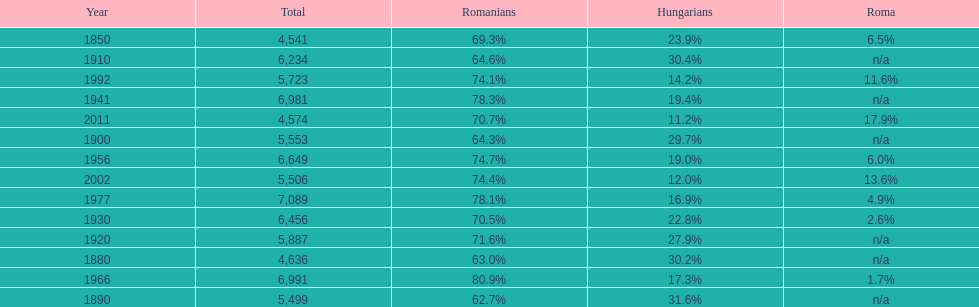Which year is previous to the year that had 74.1% in romanian population? 1977. 